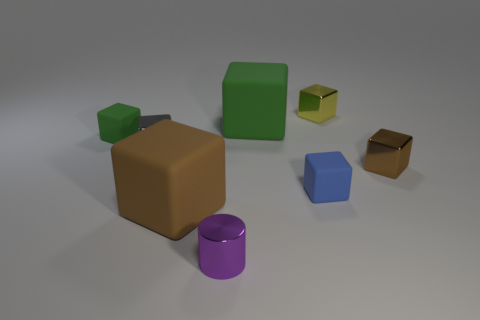There is a small block that is to the right of the tiny yellow thing; is it the same color as the large object that is on the left side of the purple shiny thing?
Make the answer very short. Yes. Are there any purple shiny objects that have the same shape as the small blue object?
Your answer should be compact. No. Are there the same number of tiny gray things that are in front of the tiny blue matte thing and cylinders that are on the right side of the tiny yellow cube?
Offer a very short reply. Yes. Is there anything else that has the same size as the gray object?
Keep it short and to the point. Yes. What number of purple objects are tiny metallic blocks or small shiny cylinders?
Keep it short and to the point. 1. How many blue rubber spheres have the same size as the cylinder?
Provide a succinct answer. 0. What is the color of the small cube that is to the left of the yellow object and on the right side of the tiny purple metallic object?
Offer a very short reply. Blue. Are there more small metal blocks that are on the right side of the big green cube than big yellow rubber balls?
Your answer should be very brief. Yes. Is there a green object?
Ensure brevity in your answer.  Yes. What number of big things are either metallic cubes or purple cylinders?
Ensure brevity in your answer.  0. 